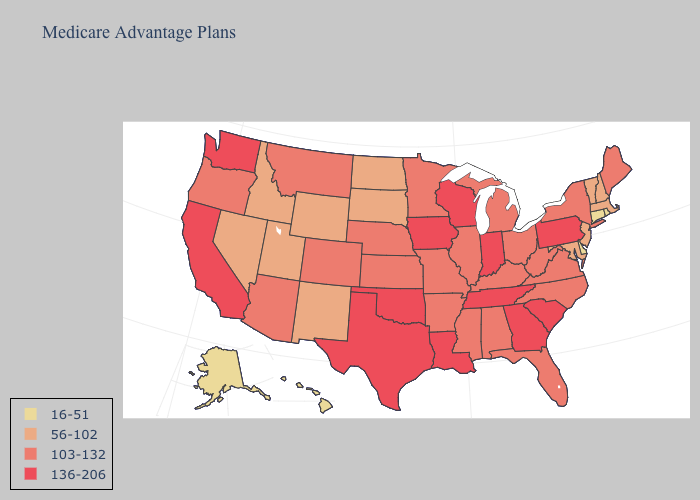What is the highest value in states that border Vermont?
Give a very brief answer. 103-132. Name the states that have a value in the range 103-132?
Give a very brief answer. Alabama, Arkansas, Arizona, Colorado, Florida, Illinois, Kansas, Kentucky, Maine, Michigan, Minnesota, Missouri, Mississippi, Montana, North Carolina, Nebraska, New York, Ohio, Oregon, Virginia, West Virginia. What is the highest value in the USA?
Be succinct. 136-206. Name the states that have a value in the range 136-206?
Write a very short answer. California, Georgia, Iowa, Indiana, Louisiana, Oklahoma, Pennsylvania, South Carolina, Tennessee, Texas, Washington, Wisconsin. Does the first symbol in the legend represent the smallest category?
Short answer required. Yes. Name the states that have a value in the range 56-102?
Concise answer only. Idaho, Massachusetts, Maryland, North Dakota, New Hampshire, New Jersey, New Mexico, Nevada, South Dakota, Utah, Vermont, Wyoming. Does the first symbol in the legend represent the smallest category?
Keep it brief. Yes. Does Vermont have a lower value than New Jersey?
Short answer required. No. Is the legend a continuous bar?
Keep it brief. No. What is the value of Maryland?
Keep it brief. 56-102. What is the value of Mississippi?
Quick response, please. 103-132. How many symbols are there in the legend?
Short answer required. 4. Name the states that have a value in the range 16-51?
Write a very short answer. Alaska, Connecticut, Delaware, Hawaii, Rhode Island. Name the states that have a value in the range 56-102?
Short answer required. Idaho, Massachusetts, Maryland, North Dakota, New Hampshire, New Jersey, New Mexico, Nevada, South Dakota, Utah, Vermont, Wyoming. What is the highest value in the USA?
Be succinct. 136-206. 